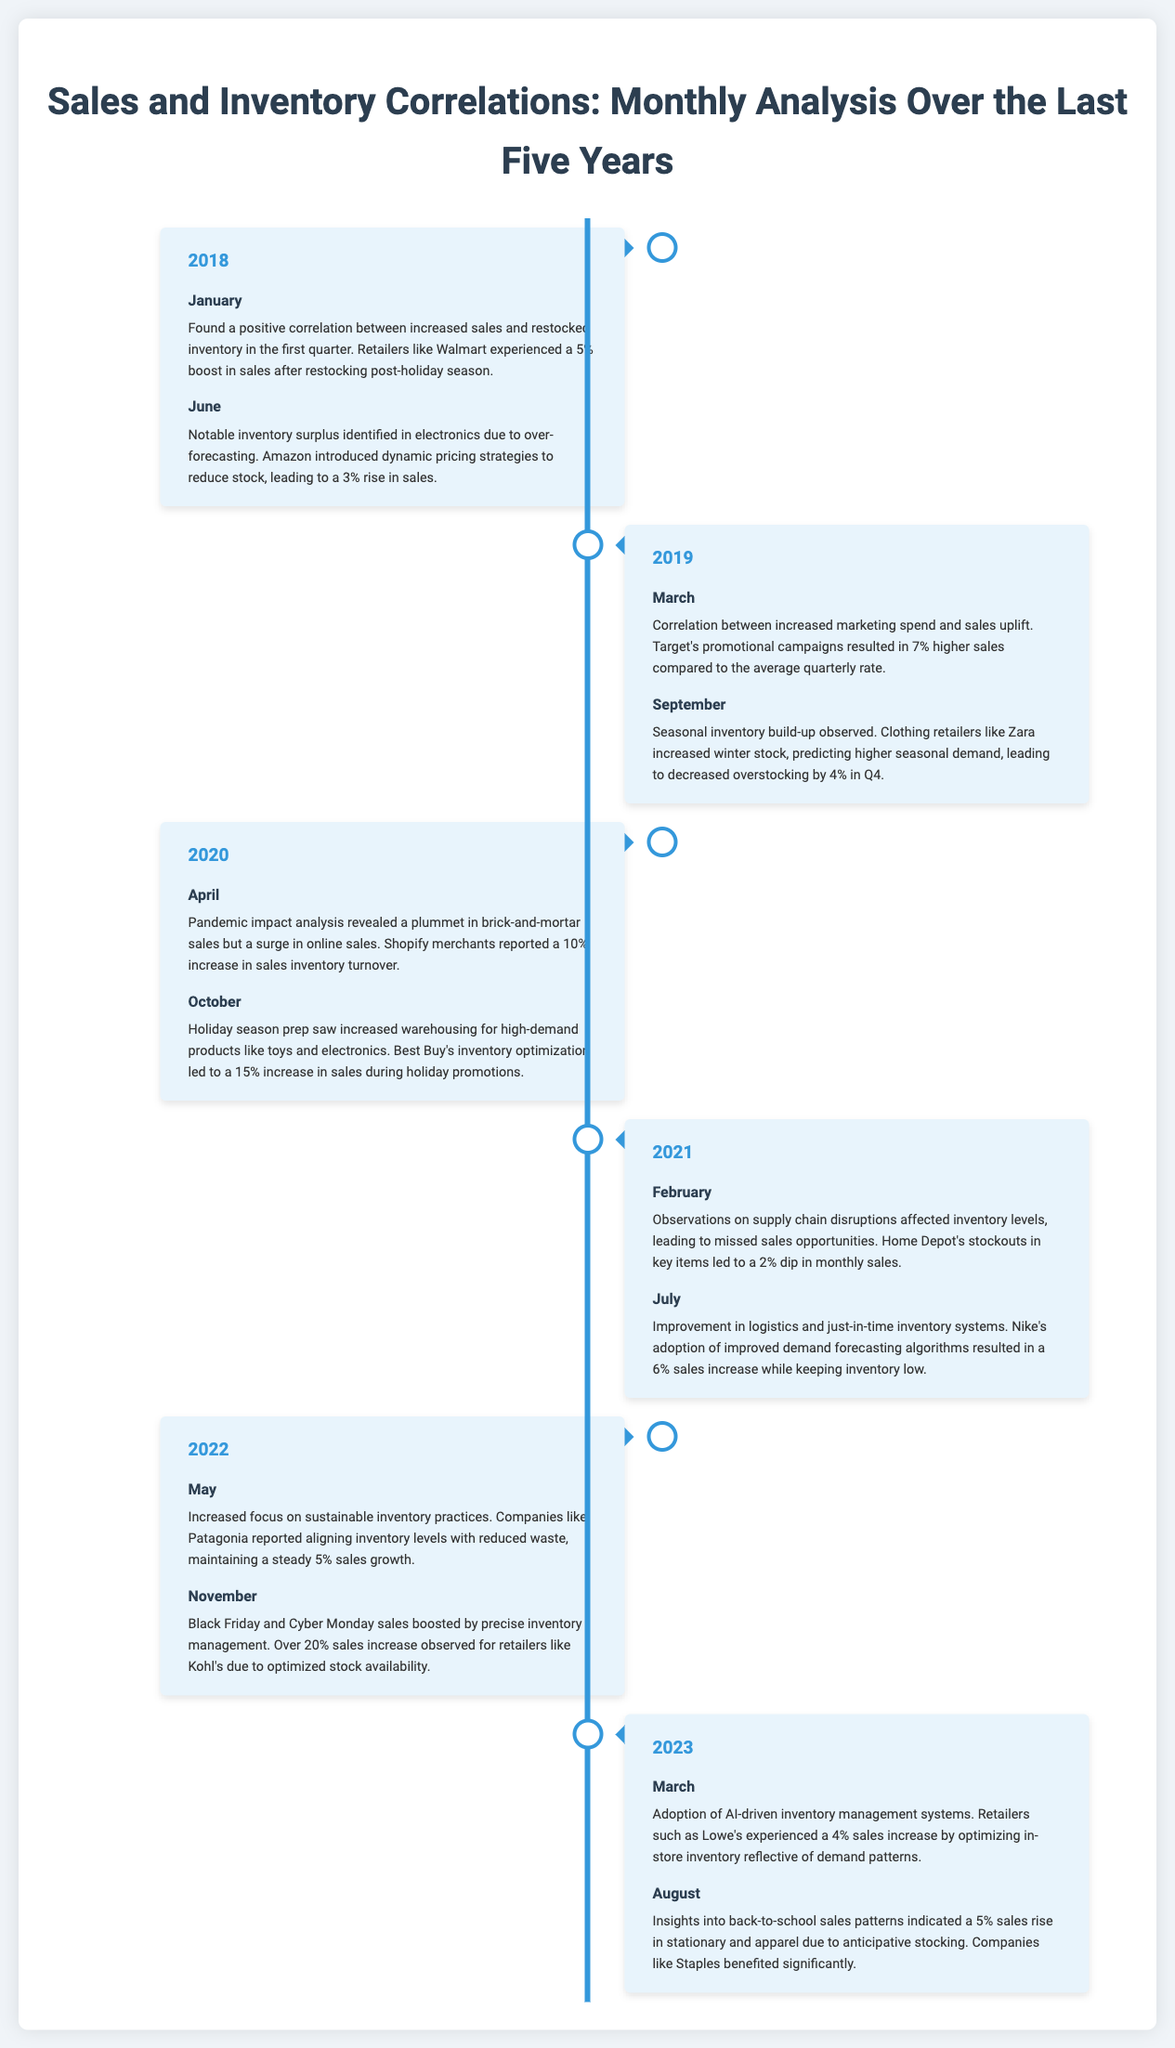What notable event occurred in January 2018? In January 2018, a positive correlation was found between increased sales and restocked inventory.
Answer: Positive correlation Which retailer experienced a 5% boost in sales after restocking in 2018? Walmart experienced a 5% boost in sales after restocking post-holiday season in January 2018.
Answer: Walmart What percentage increase in sales did Shopify merchants report in April 2020? Shopify merchants reported a 10% increase in sales inventory turnover in April 2020.
Answer: 10% In which month and year did Home Depot experience a dip in sales? Home Depot experienced a 2% dip in monthly sales in February 2021 due to supply chain disruptions.
Answer: February 2021 What sales increase did Kohl's observe during Black Friday and Cyber Monday in 2022? During Black Friday and Cyber Monday in 2022, Kohl's observed a sales increase of over 20% due to optimized stock availability.
Answer: Over 20% What was the focus of inventory practices highlighted in May 2022? The focus was on sustainable inventory practices, with companies like Patagonia aligning inventory levels with reduced waste.
Answer: Sustainable inventory practices Which retailer's inventory optimization led to a 15% increase in sales during holiday promotions in October 2020? Best Buy's inventory optimization led to a 15% increase in sales during holiday promotions in October 2020.
Answer: Best Buy What month indicated a 5% sales rise in stationary and apparel due to anticipative stocking in 2023? August 2023 indicated a 5% sales rise in stationary and apparel due to anticipative stocking.
Answer: August 2023 What was a strategy used by Amazon in June 2018 to reduce stock surplus? Amazon introduced dynamic pricing strategies to reduce stock surplus identified in June 2018.
Answer: Dynamic pricing strategies 